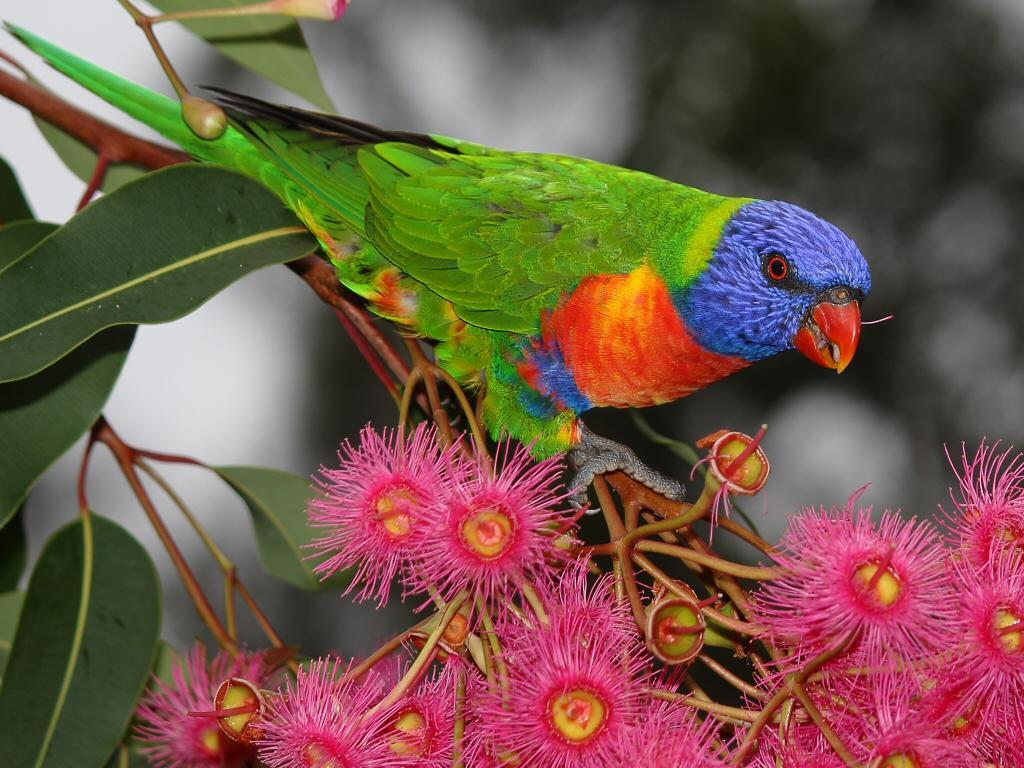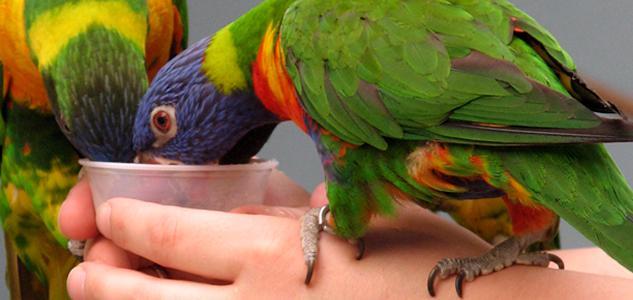The first image is the image on the left, the second image is the image on the right. Examine the images to the left and right. Is the description "An image contains a single colorful bird perched near hot pink flowers with tendril-like petals." accurate? Answer yes or no. Yes. The first image is the image on the left, the second image is the image on the right. Considering the images on both sides, is "In one of the images a colorful bird is sitting on a branch next to some bright pink flowers." valid? Answer yes or no. Yes. 